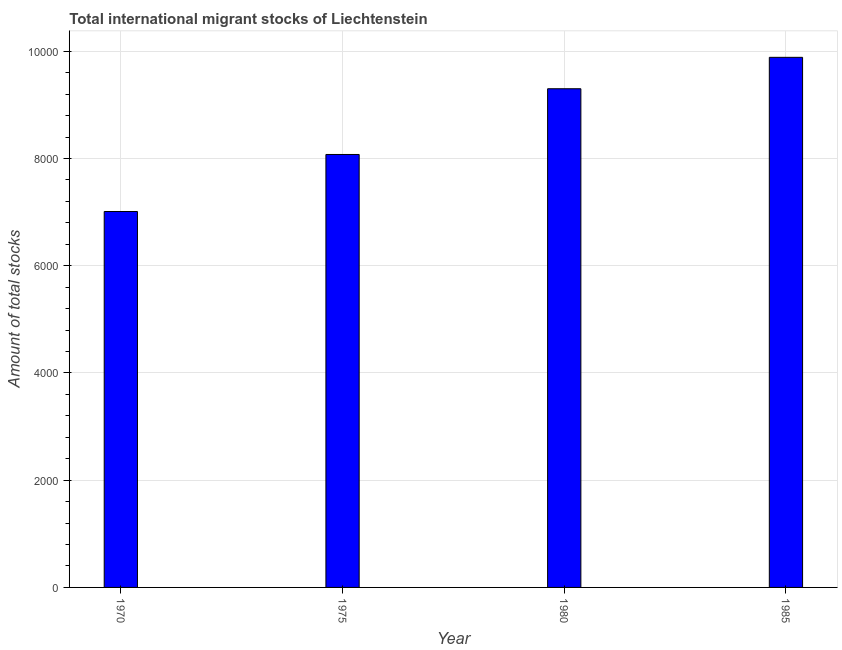Does the graph contain any zero values?
Offer a very short reply. No. What is the title of the graph?
Make the answer very short. Total international migrant stocks of Liechtenstein. What is the label or title of the Y-axis?
Ensure brevity in your answer.  Amount of total stocks. What is the total number of international migrant stock in 1985?
Ensure brevity in your answer.  9888. Across all years, what is the maximum total number of international migrant stock?
Your answer should be very brief. 9888. Across all years, what is the minimum total number of international migrant stock?
Offer a very short reply. 7012. In which year was the total number of international migrant stock minimum?
Provide a succinct answer. 1970. What is the sum of the total number of international migrant stock?
Your answer should be very brief. 3.43e+04. What is the difference between the total number of international migrant stock in 1975 and 1985?
Offer a very short reply. -1812. What is the average total number of international migrant stock per year?
Offer a very short reply. 8569. What is the median total number of international migrant stock?
Offer a terse response. 8689. What is the ratio of the total number of international migrant stock in 1970 to that in 1975?
Provide a short and direct response. 0.87. Is the total number of international migrant stock in 1975 less than that in 1985?
Make the answer very short. Yes. What is the difference between the highest and the second highest total number of international migrant stock?
Ensure brevity in your answer.  586. What is the difference between the highest and the lowest total number of international migrant stock?
Keep it short and to the point. 2876. In how many years, is the total number of international migrant stock greater than the average total number of international migrant stock taken over all years?
Keep it short and to the point. 2. How many bars are there?
Your response must be concise. 4. Are all the bars in the graph horizontal?
Your response must be concise. No. How many years are there in the graph?
Give a very brief answer. 4. Are the values on the major ticks of Y-axis written in scientific E-notation?
Offer a very short reply. No. What is the Amount of total stocks of 1970?
Offer a terse response. 7012. What is the Amount of total stocks in 1975?
Give a very brief answer. 8076. What is the Amount of total stocks in 1980?
Ensure brevity in your answer.  9302. What is the Amount of total stocks in 1985?
Provide a succinct answer. 9888. What is the difference between the Amount of total stocks in 1970 and 1975?
Provide a short and direct response. -1064. What is the difference between the Amount of total stocks in 1970 and 1980?
Keep it short and to the point. -2290. What is the difference between the Amount of total stocks in 1970 and 1985?
Make the answer very short. -2876. What is the difference between the Amount of total stocks in 1975 and 1980?
Your response must be concise. -1226. What is the difference between the Amount of total stocks in 1975 and 1985?
Offer a very short reply. -1812. What is the difference between the Amount of total stocks in 1980 and 1985?
Give a very brief answer. -586. What is the ratio of the Amount of total stocks in 1970 to that in 1975?
Offer a terse response. 0.87. What is the ratio of the Amount of total stocks in 1970 to that in 1980?
Give a very brief answer. 0.75. What is the ratio of the Amount of total stocks in 1970 to that in 1985?
Your answer should be compact. 0.71. What is the ratio of the Amount of total stocks in 1975 to that in 1980?
Ensure brevity in your answer.  0.87. What is the ratio of the Amount of total stocks in 1975 to that in 1985?
Offer a very short reply. 0.82. What is the ratio of the Amount of total stocks in 1980 to that in 1985?
Offer a terse response. 0.94. 